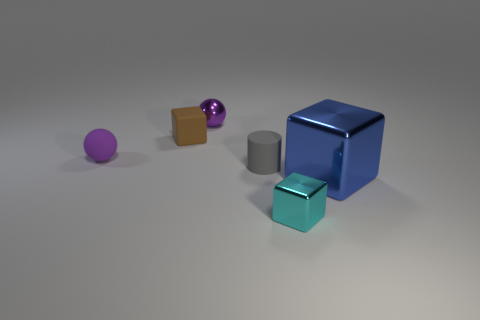Is there any other thing that has the same size as the blue metallic object?
Give a very brief answer. No. The metallic ball that is the same color as the rubber sphere is what size?
Give a very brief answer. Small. Is the purple object in front of the small brown cube made of the same material as the cylinder?
Your answer should be very brief. Yes. Is the number of purple balls that are to the right of the large blue metal cube the same as the number of big blue cubes that are in front of the cyan object?
Make the answer very short. Yes. There is a object that is on the right side of the purple metallic object and behind the blue metal object; what is its shape?
Keep it short and to the point. Cylinder. What number of rubber blocks are behind the small gray object?
Your answer should be very brief. 1. How many other things are the same shape as the big blue thing?
Ensure brevity in your answer.  2. Is the number of tiny metal spheres less than the number of shiny things?
Provide a succinct answer. Yes. There is a object that is on the right side of the purple metal object and behind the big cube; how big is it?
Make the answer very short. Small. There is a metallic object that is on the left side of the cube in front of the metallic cube that is behind the cyan object; how big is it?
Your response must be concise. Small. 